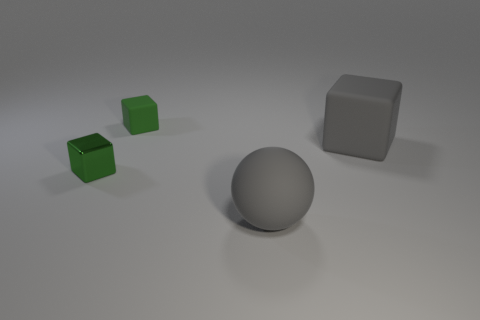Subtract 2 cubes. How many cubes are left? 1 Add 2 tiny green metal objects. How many objects exist? 6 Subtract all small green cubes. How many cubes are left? 1 Subtract all cubes. How many objects are left? 1 Subtract all purple cubes. Subtract all yellow cylinders. How many cubes are left? 3 Subtract all blue balls. How many green blocks are left? 2 Subtract all small cyan cubes. Subtract all gray things. How many objects are left? 2 Add 1 gray matte things. How many gray matte things are left? 3 Add 3 small shiny objects. How many small shiny objects exist? 4 Subtract all gray cubes. How many cubes are left? 2 